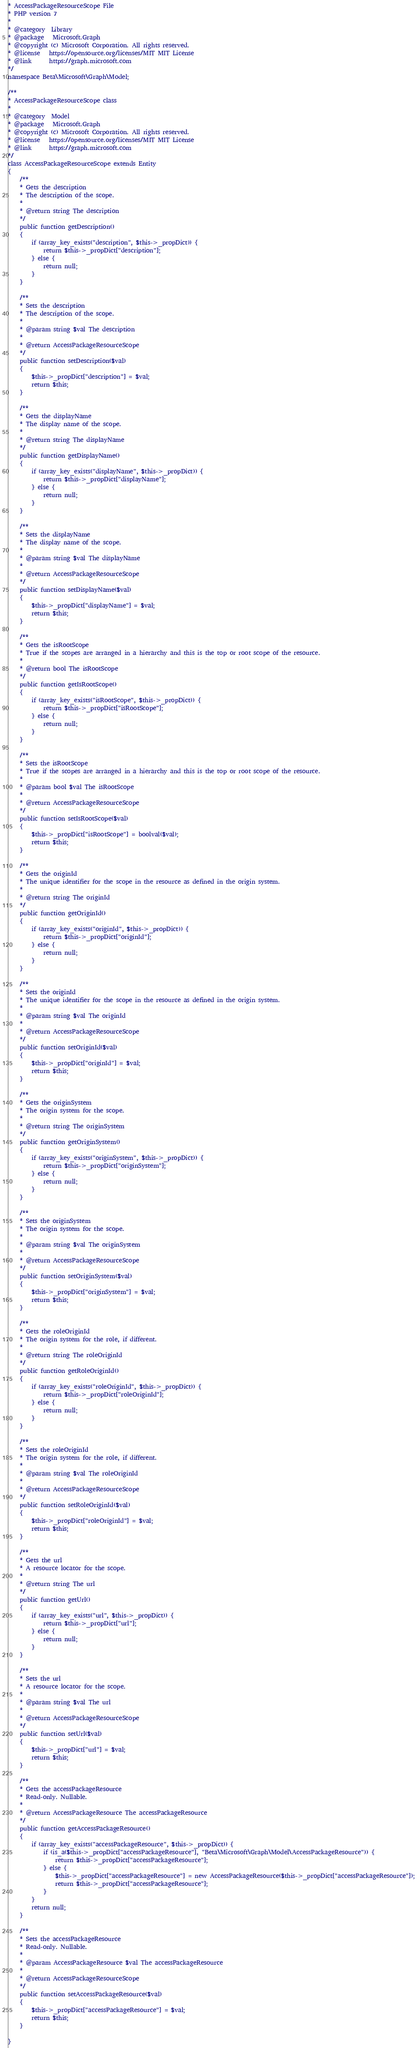Convert code to text. <code><loc_0><loc_0><loc_500><loc_500><_PHP_>* AccessPackageResourceScope File
* PHP version 7
*
* @category  Library
* @package   Microsoft.Graph
* @copyright (c) Microsoft Corporation. All rights reserved.
* @license   https://opensource.org/licenses/MIT MIT License
* @link      https://graph.microsoft.com
*/
namespace Beta\Microsoft\Graph\Model;

/**
* AccessPackageResourceScope class
*
* @category  Model
* @package   Microsoft.Graph
* @copyright (c) Microsoft Corporation. All rights reserved.
* @license   https://opensource.org/licenses/MIT MIT License
* @link      https://graph.microsoft.com
*/
class AccessPackageResourceScope extends Entity
{
    /**
    * Gets the description
    * The description of the scope.
    *
    * @return string The description
    */
    public function getDescription()
    {
        if (array_key_exists("description", $this->_propDict)) {
            return $this->_propDict["description"];
        } else {
            return null;
        }
    }
    
    /**
    * Sets the description
    * The description of the scope.
    *
    * @param string $val The description
    *
    * @return AccessPackageResourceScope
    */
    public function setDescription($val)
    {
        $this->_propDict["description"] = $val;
        return $this;
    }
    
    /**
    * Gets the displayName
    * The display name of the scope.
    *
    * @return string The displayName
    */
    public function getDisplayName()
    {
        if (array_key_exists("displayName", $this->_propDict)) {
            return $this->_propDict["displayName"];
        } else {
            return null;
        }
    }
    
    /**
    * Sets the displayName
    * The display name of the scope.
    *
    * @param string $val The displayName
    *
    * @return AccessPackageResourceScope
    */
    public function setDisplayName($val)
    {
        $this->_propDict["displayName"] = $val;
        return $this;
    }
    
    /**
    * Gets the isRootScope
    * True if the scopes are arranged in a hierarchy and this is the top or root scope of the resource.
    *
    * @return bool The isRootScope
    */
    public function getIsRootScope()
    {
        if (array_key_exists("isRootScope", $this->_propDict)) {
            return $this->_propDict["isRootScope"];
        } else {
            return null;
        }
    }
    
    /**
    * Sets the isRootScope
    * True if the scopes are arranged in a hierarchy and this is the top or root scope of the resource.
    *
    * @param bool $val The isRootScope
    *
    * @return AccessPackageResourceScope
    */
    public function setIsRootScope($val)
    {
        $this->_propDict["isRootScope"] = boolval($val);
        return $this;
    }
    
    /**
    * Gets the originId
    * The unique identifier for the scope in the resource as defined in the origin system.
    *
    * @return string The originId
    */
    public function getOriginId()
    {
        if (array_key_exists("originId", $this->_propDict)) {
            return $this->_propDict["originId"];
        } else {
            return null;
        }
    }
    
    /**
    * Sets the originId
    * The unique identifier for the scope in the resource as defined in the origin system.
    *
    * @param string $val The originId
    *
    * @return AccessPackageResourceScope
    */
    public function setOriginId($val)
    {
        $this->_propDict["originId"] = $val;
        return $this;
    }
    
    /**
    * Gets the originSystem
    * The origin system for the scope.
    *
    * @return string The originSystem
    */
    public function getOriginSystem()
    {
        if (array_key_exists("originSystem", $this->_propDict)) {
            return $this->_propDict["originSystem"];
        } else {
            return null;
        }
    }
    
    /**
    * Sets the originSystem
    * The origin system for the scope.
    *
    * @param string $val The originSystem
    *
    * @return AccessPackageResourceScope
    */
    public function setOriginSystem($val)
    {
        $this->_propDict["originSystem"] = $val;
        return $this;
    }
    
    /**
    * Gets the roleOriginId
    * The origin system for the role, if different.
    *
    * @return string The roleOriginId
    */
    public function getRoleOriginId()
    {
        if (array_key_exists("roleOriginId", $this->_propDict)) {
            return $this->_propDict["roleOriginId"];
        } else {
            return null;
        }
    }
    
    /**
    * Sets the roleOriginId
    * The origin system for the role, if different.
    *
    * @param string $val The roleOriginId
    *
    * @return AccessPackageResourceScope
    */
    public function setRoleOriginId($val)
    {
        $this->_propDict["roleOriginId"] = $val;
        return $this;
    }
    
    /**
    * Gets the url
    * A resource locator for the scope.
    *
    * @return string The url
    */
    public function getUrl()
    {
        if (array_key_exists("url", $this->_propDict)) {
            return $this->_propDict["url"];
        } else {
            return null;
        }
    }
    
    /**
    * Sets the url
    * A resource locator for the scope.
    *
    * @param string $val The url
    *
    * @return AccessPackageResourceScope
    */
    public function setUrl($val)
    {
        $this->_propDict["url"] = $val;
        return $this;
    }
    
    /**
    * Gets the accessPackageResource
    * Read-only. Nullable.
    *
    * @return AccessPackageResource The accessPackageResource
    */
    public function getAccessPackageResource()
    {
        if (array_key_exists("accessPackageResource", $this->_propDict)) {
            if (is_a($this->_propDict["accessPackageResource"], "Beta\Microsoft\Graph\Model\AccessPackageResource")) {
                return $this->_propDict["accessPackageResource"];
            } else {
                $this->_propDict["accessPackageResource"] = new AccessPackageResource($this->_propDict["accessPackageResource"]);
                return $this->_propDict["accessPackageResource"];
            }
        }
        return null;
    }
    
    /**
    * Sets the accessPackageResource
    * Read-only. Nullable.
    *
    * @param AccessPackageResource $val The accessPackageResource
    *
    * @return AccessPackageResourceScope
    */
    public function setAccessPackageResource($val)
    {
        $this->_propDict["accessPackageResource"] = $val;
        return $this;
    }
    
}</code> 